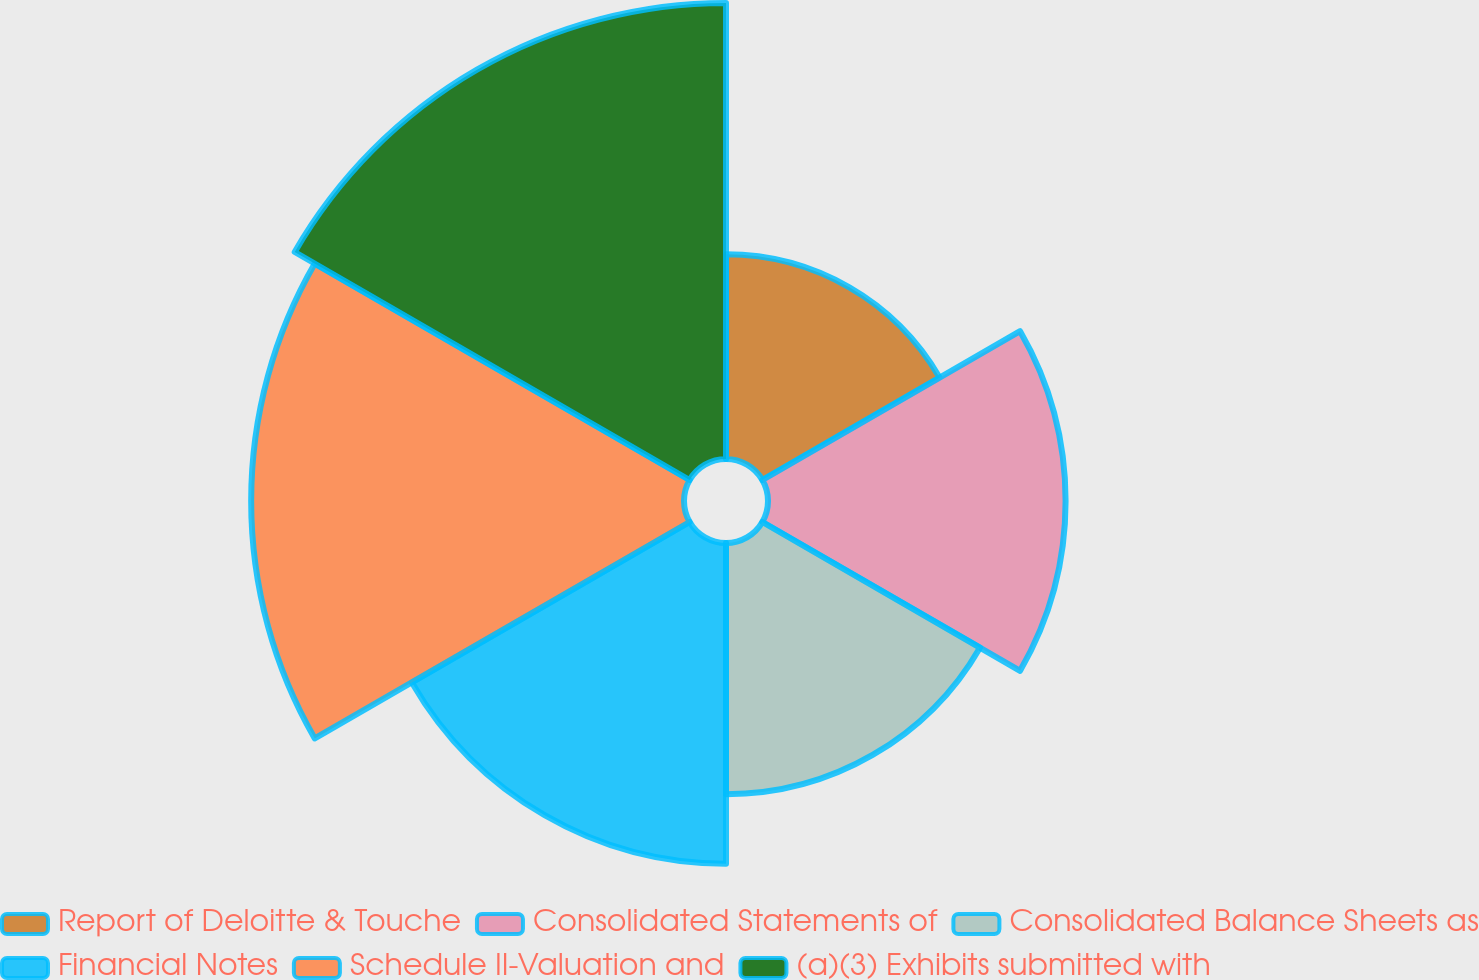Convert chart. <chart><loc_0><loc_0><loc_500><loc_500><pie_chart><fcel>Report of Deloitte & Touche<fcel>Consolidated Statements of<fcel>Consolidated Balance Sheets as<fcel>Financial Notes<fcel>Schedule II-Valuation and<fcel>(a)(3) Exhibits submitted with<nl><fcel>10.43%<fcel>15.16%<fcel>12.8%<fcel>16.34%<fcel>22.05%<fcel>23.23%<nl></chart> 